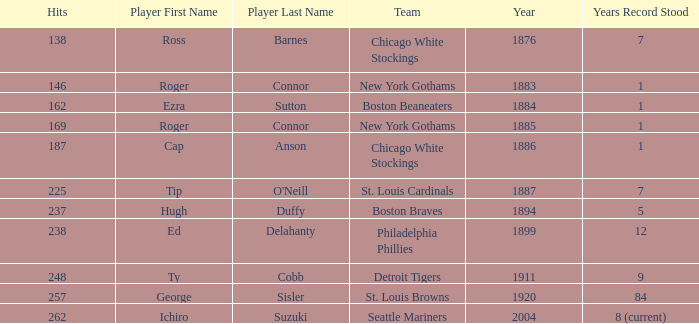Name the player with 238 hits and years after 1885 Ed Delahanty. 